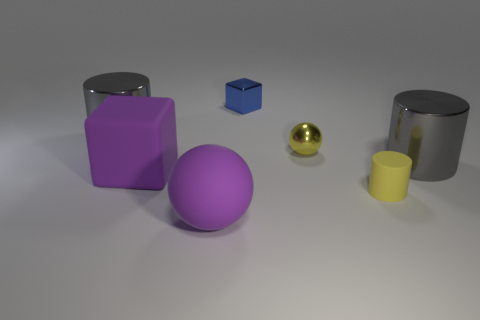Is there a thing of the same color as the matte cylinder?
Offer a very short reply. Yes. Are there any cubes?
Provide a short and direct response. Yes. Is the yellow object that is in front of the yellow sphere made of the same material as the blue thing?
Keep it short and to the point. No. What is the size of the rubber object that is the same color as the large rubber cube?
Ensure brevity in your answer.  Large. What number of yellow matte objects are the same size as the blue shiny thing?
Offer a terse response. 1. Is the number of big rubber balls that are in front of the tiny yellow rubber cylinder the same as the number of small brown matte things?
Your answer should be very brief. No. What number of gray shiny cylinders are on the left side of the large purple matte cube and in front of the tiny yellow sphere?
Keep it short and to the point. 0. What size is the yellow sphere that is the same material as the blue object?
Your response must be concise. Small. What number of green metallic things have the same shape as the tiny blue shiny thing?
Your answer should be compact. 0. Are there more cylinders right of the big purple rubber ball than yellow metal spheres?
Offer a terse response. Yes. 